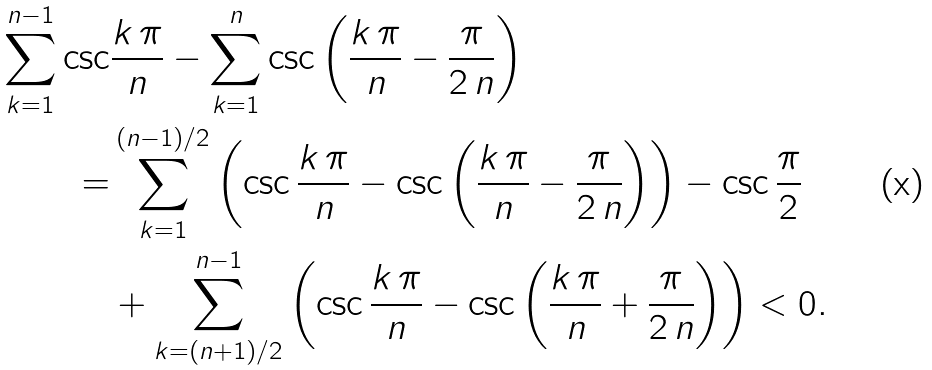Convert formula to latex. <formula><loc_0><loc_0><loc_500><loc_500>\sum _ { k = 1 } ^ { n - 1 } \csc & \frac { k \, \pi } { n } - \sum _ { k = 1 } ^ { n } \csc \left ( \frac { k \, \pi } { n } - \frac { \pi } { 2 \, n } \right ) \\ = & \sum _ { k = 1 } ^ { ( n - 1 ) / 2 } \left ( \csc \frac { k \, \pi } { n } - \csc \left ( \frac { k \, \pi } { n } - \frac { \pi } { 2 \, n } \right ) \right ) - \csc \frac { \pi } { 2 } \\ & + \sum _ { k = ( n + 1 ) / 2 } ^ { n - 1 } \left ( \csc \frac { k \, \pi } { n } - \csc \left ( \frac { k \, \pi } { n } + \frac { \pi } { 2 \, n } \right ) \right ) < 0 .</formula> 